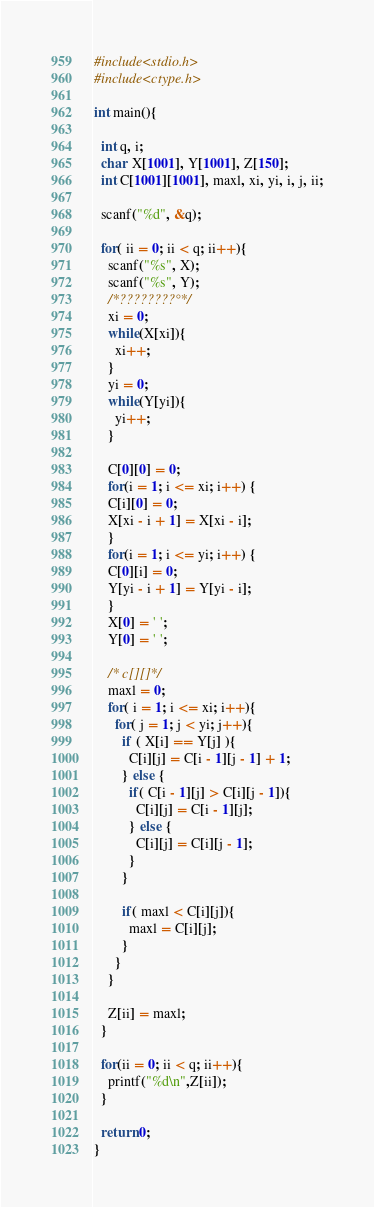Convert code to text. <code><loc_0><loc_0><loc_500><loc_500><_C_>#include<stdio.h>
#include<ctype.h>

int main(){
  
  int q, i;
  char  X[1001], Y[1001], Z[150];
  int C[1001][1001], maxl, xi, yi, i, j, ii;
  
  scanf("%d", &q);
  
  for( ii = 0; ii < q; ii++){
    scanf("%s", X);
    scanf("%s", Y);
    /*????????°*/
    xi = 0;
    while(X[xi]){
      xi++;
    }
    yi = 0;
    while(Y[yi]){
      yi++;
    }
    
    C[0][0] = 0;
    for(i = 1; i <= xi; i++) {
    C[i][0] = 0;
    X[xi - i + 1] = X[xi - i];
    }
    for(i = 1; i <= yi; i++) {
    C[0][i] = 0;
    Y[yi - i + 1] = Y[yi - i];
    }
    X[0] = ' ';
    Y[0] = ' ';

    /* c[][]*/
    maxl = 0;
    for( i = 1; i <= xi; i++){
      for( j = 1; j < yi; j++){
        if ( X[i] == Y[j] ){
          C[i][j] = C[i - 1][j - 1] + 1;
        } else {
          if( C[i - 1][j] > C[i][j - 1]){
            C[i][j] = C[i - 1][j];
          } else {
            C[i][j] = C[i][j - 1];
          }
        }
        
        if( maxl < C[i][j]){
          maxl = C[i][j];
        }
      }
    }
    
    Z[ii] = maxl;
  }
  
  for(ii = 0; ii < q; ii++){
    printf("%d\n",Z[ii]);
  }
  
  return 0;
}</code> 